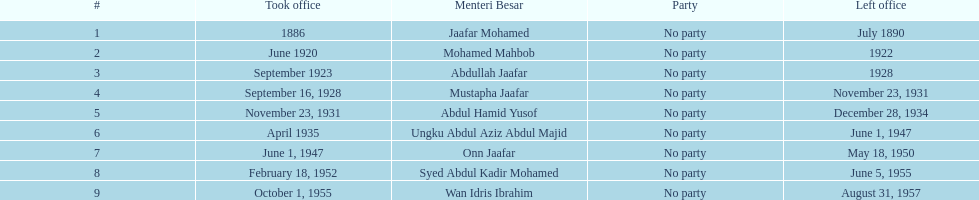How many years was jaafar mohamed in office? 4. 